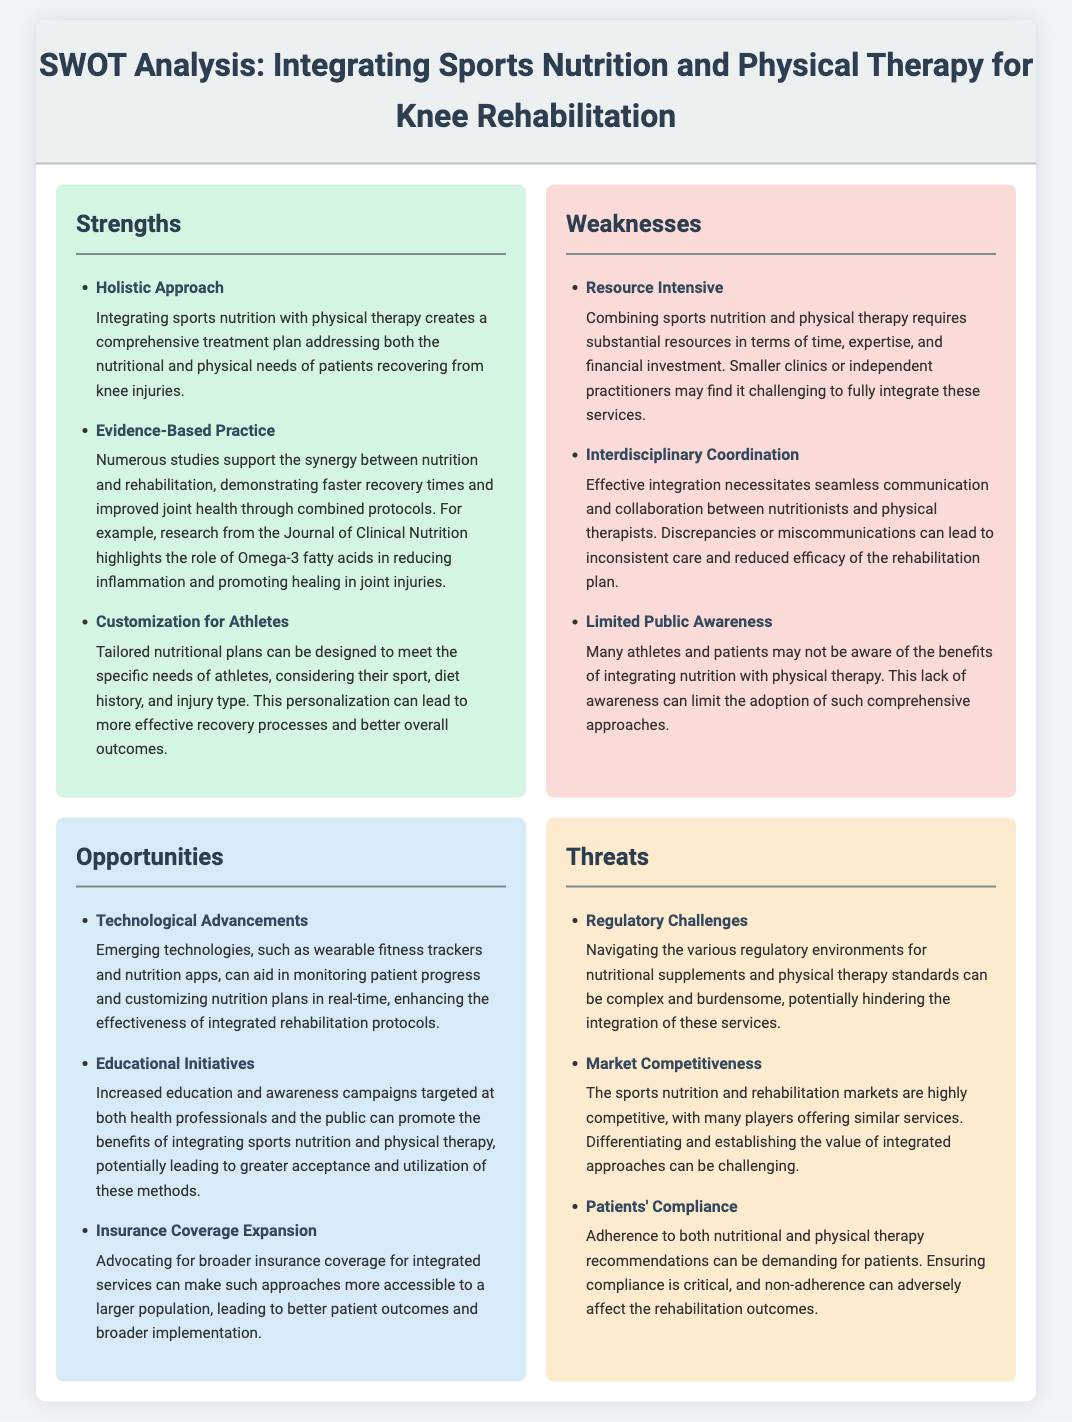What is the first strength mentioned in the SWOT analysis? The first strength mentioned is "Holistic Approach" in the strengths section of the document.
Answer: Holistic Approach What is a major weakness identified in the document? A major weakness is "Resource Intensive," highlighting the demands required to integrate sports nutrition and physical therapy.
Answer: Resource Intensive How many opportunities are listed in the analysis? There are three opportunities listed in the opportunities section of the document.
Answer: 3 Which threat discusses compliance issues? The threat that discusses compliance issues is "Patients' Compliance," which addresses the challenges in adhering to treatment plans.
Answer: Patients' Compliance What is one example of an educational initiative mentioned? The document mentions "Increased education and awareness campaigns" as a specific example of educational initiatives aimed at promoting integration.
Answer: Increased education and awareness campaigns What role do Omega-3 fatty acids play according to the analysis? Omega-3 fatty acids are highlighted as reducing inflammation and promoting healing in joint injuries.
Answer: Reducing inflammation and promoting healing What type of communication is necessary for effective integration? "Seamless communication" is necessary for effective integration between nutritionists and physical therapists.
Answer: Seamless communication What can enhance the effectiveness of rehabilitation protocols? Emerging technologies like wearable fitness trackers and nutrition apps can enhance the effectiveness of rehabilitation protocols.
Answer: Emerging technologies What is a potential barrier to integration mentioned in the threats? "Regulatory Challenges" are identified as a potential barrier to the integration of nutrition and physical therapy services.
Answer: Regulatory Challenges 